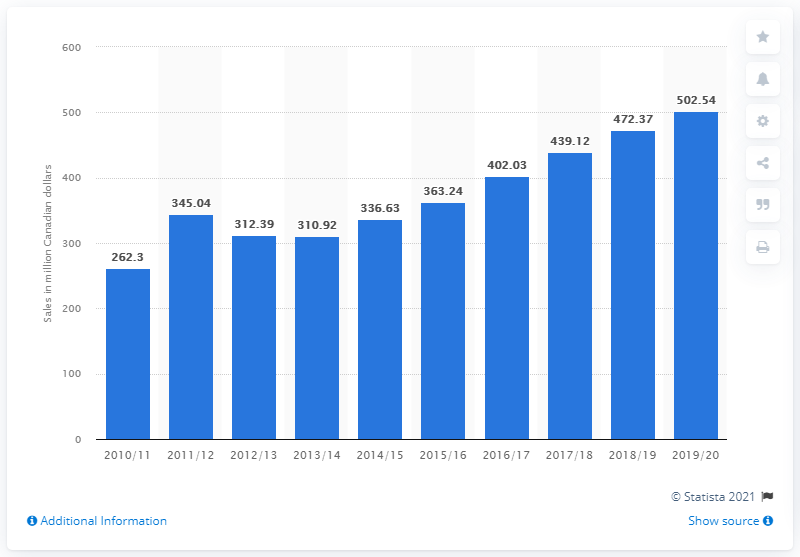List a handful of essential elements in this visual. The sales value of sparkling wine in Canada in 2011 was 472.37. The sales value of sparkling wine in Canada during the fiscal year ending March 31, 2020 was CAD 502.54. 